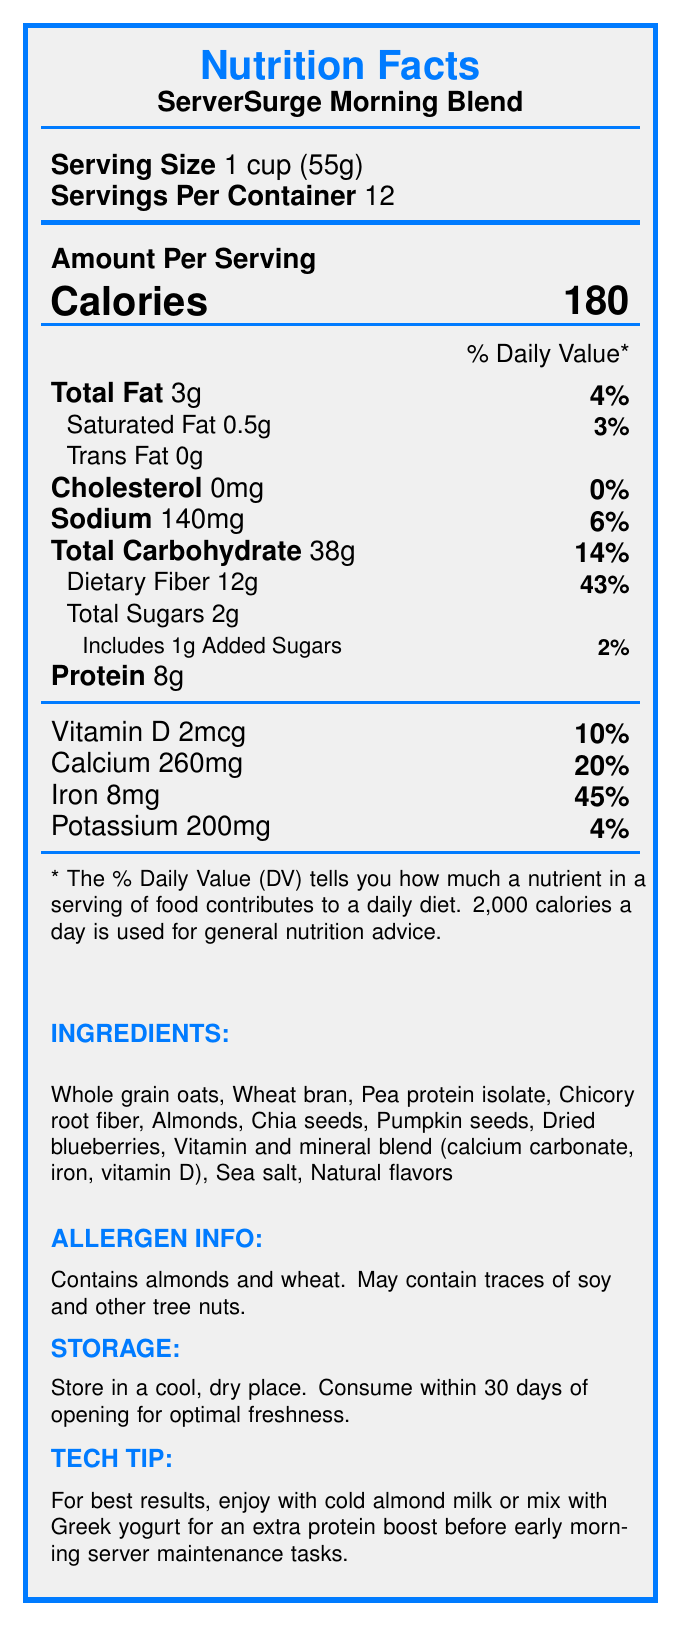what is the serving size of "ServerSurge Morning Blend"? The document states that the serving size is 1 cup (55g).
Answer: 1 cup (55g) how many calories are there per serving? The document lists the calories per serving as 180.
Answer: 180 what percentage of the daily value is the dietary fiber? The dietary fiber amount listed is 12g which is 43% of the daily value.
Answer: 43% how much iron is there per serving? The document indicates that there is 8mg of iron per serving.
Answer: 8mg what are the storage instructions for this cereal? The storage instructions are listed at the bottom of the document.
Answer: Store in a cool, dry place. Consume within 30 days of opening for optimal freshness. which of the following ingredients are present in the "ServerSurge Morning Blend"? A. Whole grain oats B. Cane sugar C. Almonds D. Pea protein isolate The ingredients listed include whole grain oats, almonds, and pea protein isolate, but cane sugar is not mentioned.
Answer: A, C, and D how many grams of total sugars does one serving contain? A. 1g B. 2g C. 5g D. 10g The document states that total sugars per serving is 2g.
Answer: B is the cereal fortified with vitamin D? The document indicates that the cereal contains 2mcg of vitamin D per serving, which is 10% of the daily value.
Answer: Yes does the cereal contain any allergens? The document mentions that it contains almonds and wheat and may contain traces of soy and other tree nuts.
Answer: Yes can this cereal help maintain stable blood glucose levels? The document makes the claim that it is low in sugar to maintain stable blood glucose levels.
Answer: Yes what percentage of the daily value of iron does one serving provide? The document states that one serving provides 45% of the daily value of iron.
Answer: 45% what claims are made about the benefits of this cereal for server maintenance? The document lists several claims aimed at supporting energy, cognitive function, and overall health during server maintenance.
Answer: High in fiber for sustained energy, low in sugar to maintain stable blood glucose levels, rich in proteins for improved cognitive function, contains omega-3 fatty acids for brain health, fortified with iron to combat fatigue during long maintenance sessions, added vitamin D to support immune function during night shifts what is the brand name of the cereal? The product name listed at the top of the document is "ServerSurge Morning Blend".
Answer: ServerSurge Morning Blend how many servings are there per container? The document specifies that there are 12 servings per container.
Answer: 12 how should the cereal be consumed for best results before early morning server maintenance tasks? The preparation tips section suggests consuming it with cold almond milk or Greek yogurt for an extra protein boost.
Answer: Enjoy with cold almond milk or mix with Greek yogurt what are the amounts of calcium and potassium per serving? The document lists the amounts of calcium and potassium per serving as 260mg and 200mg, respectively.
Answer: Calcium: 260mg, Potassium: 200mg is this cereal good for someone who is lactose intolerant? The document does not provide enough information on whether the product contains lactose or is specifically suitable for those who are lactose intolerant.
Answer: Cannot be determined summarize the main nutritional benefits of the "ServerSurge Morning Blend" cereal. This summary includes the main claims and benefits listed in the document, focusing on the nutritional aspects designed to support focus and health during server maintenance tasks.
Answer: The "ServerSurge Morning Blend" cereal offers several nutritional benefits such as being high in fiber for sustained energy, low in sugar to maintain stable blood glucose levels, rich in proteins for cognitive function, containing omega-3 fatty acids for brain health, fortified with iron to combat fatigue, and includes vitamin D to support immune function. 